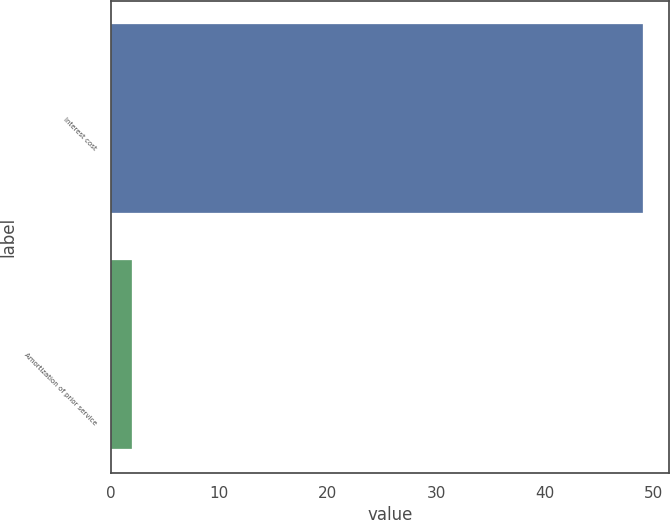Convert chart to OTSL. <chart><loc_0><loc_0><loc_500><loc_500><bar_chart><fcel>Interest cost<fcel>Amortization of prior service<nl><fcel>49<fcel>2<nl></chart> 